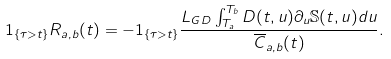<formula> <loc_0><loc_0><loc_500><loc_500>1 _ { \{ \tau > t \} } R _ { a , b } ( t ) = - 1 _ { \{ \tau > t \} } \frac { L _ { G D } \int _ { T _ { a } } ^ { T _ { b } } D ( t , u ) \partial _ { u } \mathbb { S } ( t , u ) d u } { \overline { C } _ { a , b } ( t ) } .</formula> 